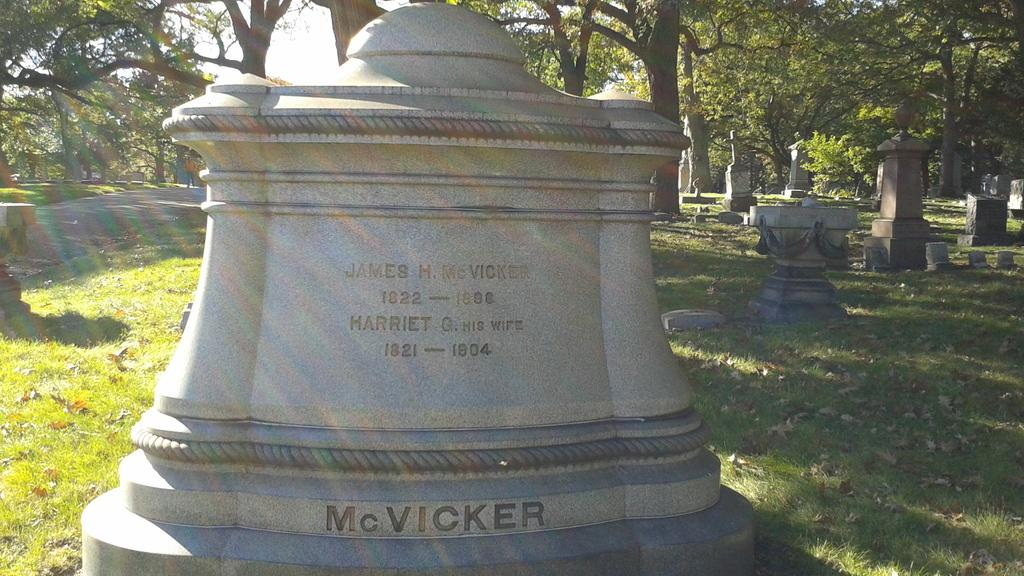What is the main object in the image? There is a headstone with writing on it in the image. Are there any other similar objects in the image? Yes, there are other headstones in the right corner of the image. What can be seen in the background of the image? There are trees in the background of the image. What flavor of ice cream is being served at the headstone in the image? There is no ice cream present in the image, and the headstone is not serving any food or beverages. 